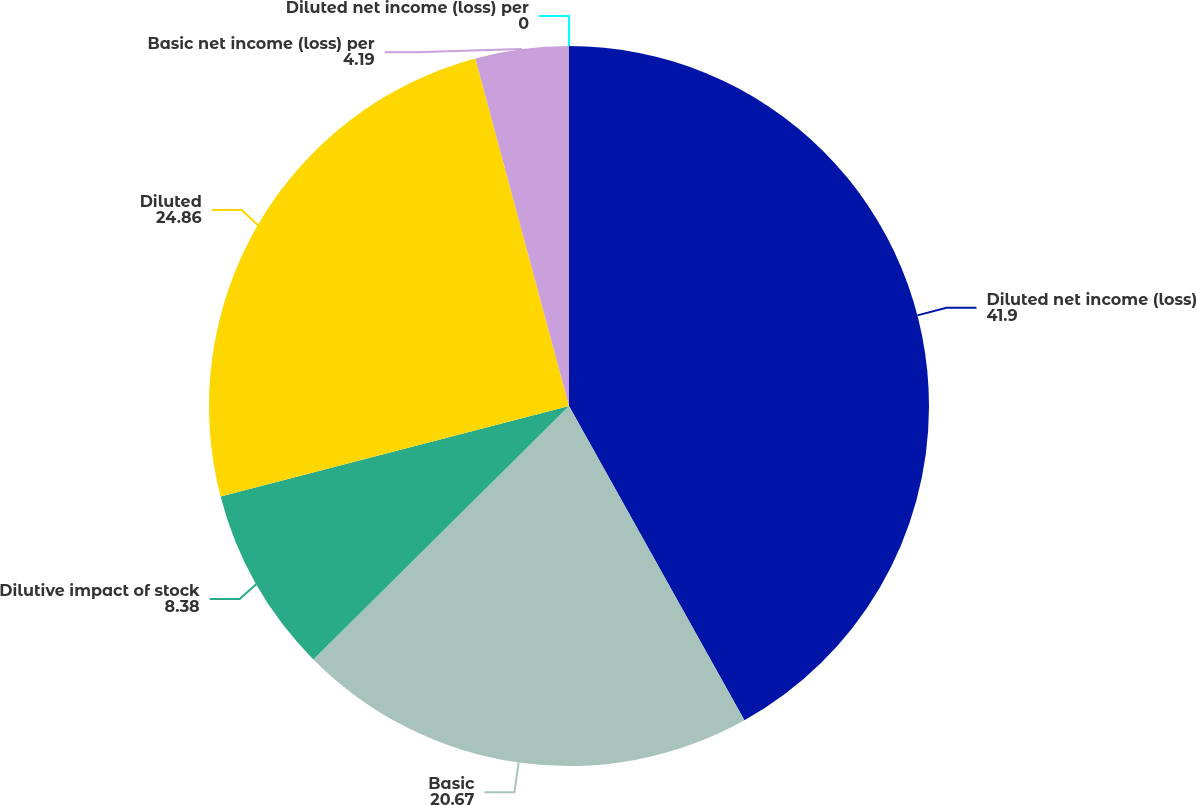Convert chart. <chart><loc_0><loc_0><loc_500><loc_500><pie_chart><fcel>Diluted net income (loss)<fcel>Basic<fcel>Dilutive impact of stock<fcel>Diluted<fcel>Basic net income (loss) per<fcel>Diluted net income (loss) per<nl><fcel>41.9%<fcel>20.67%<fcel>8.38%<fcel>24.86%<fcel>4.19%<fcel>0.0%<nl></chart> 